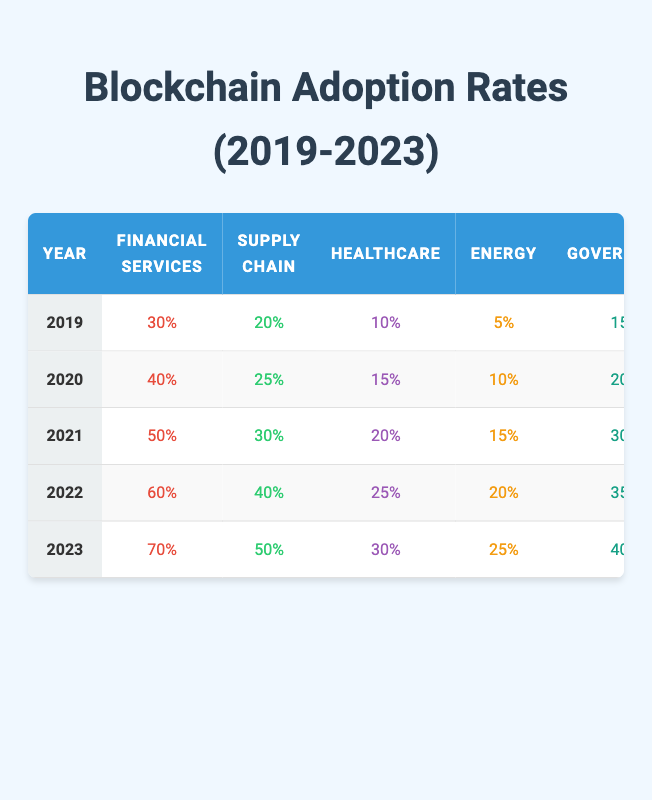What was the adoption rate of blockchain in the Healthcare sector in 2021? In 2021, the Healthcare sector's adoption rate is explicitly shown in the table as 20%.
Answer: 20% Which sector had the highest adoption rate in 2023? According to the table, Financial Services had the highest adoption rate in 2023, with a rate of 70%.
Answer: Financial Services By how much did the adoption rate in the Supply Chain sector increase from 2019 to 2023? The Supply Chain adoption rate in 2019 was 20%, and in 2023 it was 50%. The increase is calculated as 50% - 20% = 30%.
Answer: 30% What is the average adoption rate across all sectors for the year 2022? To find the average for 2022, add all sector rates: (60 + 40 + 25 + 20 + 35 + 30) = 240. Divide by the number of sectors (6): 240 / 6 = 40%.
Answer: 40% Was there a year where the adoption rate in Retail was lower than 10%? Looking at the table, the Retail sector's adoption rates were 10% in 2019 and increased thereafter. Thus, there was no year where it was below 10%.
Answer: No Which sector showed the most significant growth in adoption rate from 2019 to 2023? The Healthcare sector grew from 10% in 2019 to 30% in 2023. The increase is 30% - 10% = 20%. Other sectors had smaller growth.
Answer: Healthcare What is the difference in adoption rates between the Government and Energy sectors in 2022? The Government sector's rate in 2022 was 35% and Energy's was 20%. The difference is calculated as 35% - 20% = 15%.
Answer: 15% Which sector saw a consistent increase in adoption rates each year? All sectors listed showed an increase each year from 2019 to 2023, confirming that they consistently grew in adoption rates.
Answer: Yes What was the total adoption rate across all sectors for 2020? The total adoption rate for 2020 can be found by adding up the sector adoption rates: (40 + 25 + 15 + 10 + 20 + 15) = 125%.
Answer: 125% In which year did the Government sector first exceed a 30% adoption rate? According to the table, the Government sector surpassed 30% in 2021 when it reached 30%.
Answer: 2021 